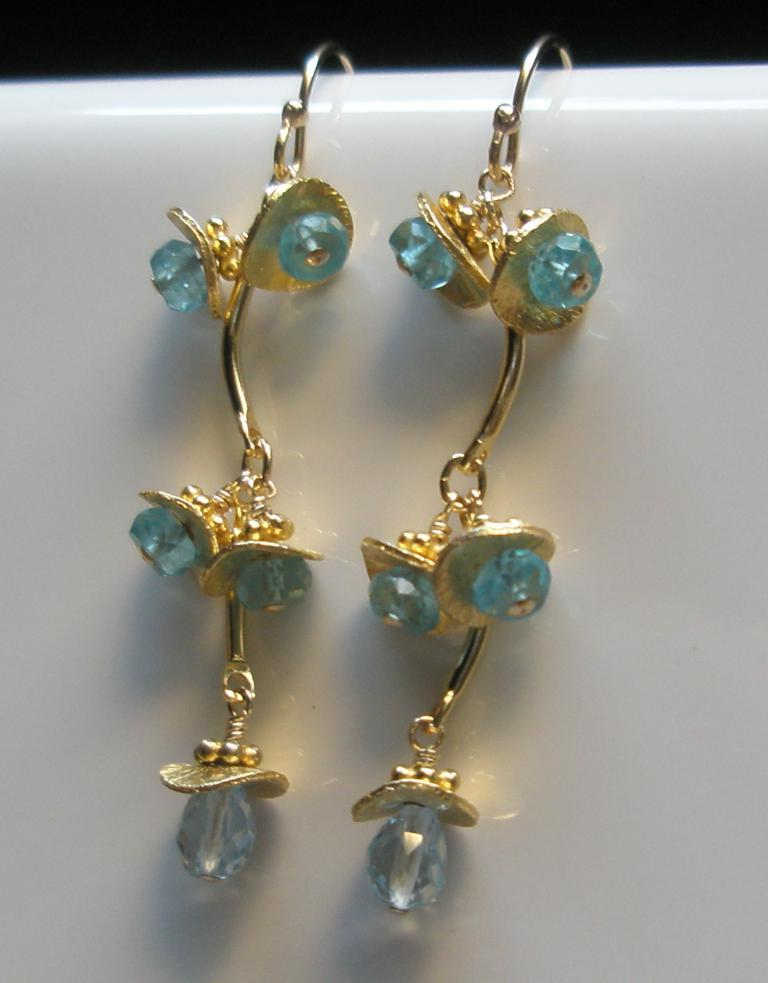What is the main subject of the image? The main subject of the image is a piece of jewelry. How is the jewelry positioned in the image? The jewelry is hanging on an object. What color is the object that the jewelry is hanging on? The object is white in color. Can you tell me how many eyes the insect has in the image? There is no insect present in the image, so it is not possible to determine the number of eyes it might have. 